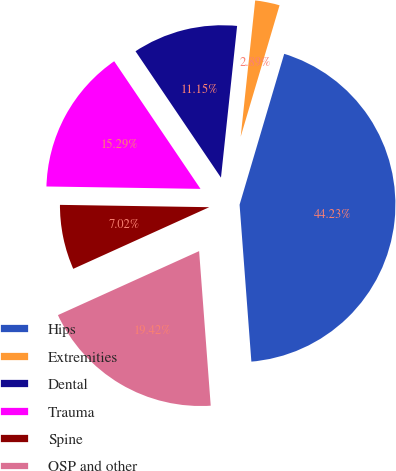<chart> <loc_0><loc_0><loc_500><loc_500><pie_chart><fcel>Hips<fcel>Extremities<fcel>Dental<fcel>Trauma<fcel>Spine<fcel>OSP and other<nl><fcel>44.23%<fcel>2.89%<fcel>11.15%<fcel>15.29%<fcel>7.02%<fcel>19.42%<nl></chart> 